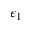<formula> <loc_0><loc_0><loc_500><loc_500>\epsilon _ { 1 }</formula> 